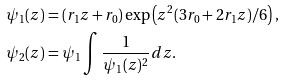Convert formula to latex. <formula><loc_0><loc_0><loc_500><loc_500>\psi _ { 1 } ( z ) & = ( r _ { 1 } z + r _ { 0 } ) \exp \left ( z ^ { 2 } ( 3 r _ { 0 } + 2 r _ { 1 } z ) / 6 \right ) , \\ \psi _ { 2 } ( z ) & = \psi _ { 1 } \int \frac { 1 } { \psi _ { 1 } ( z ) ^ { 2 } } d z .</formula> 